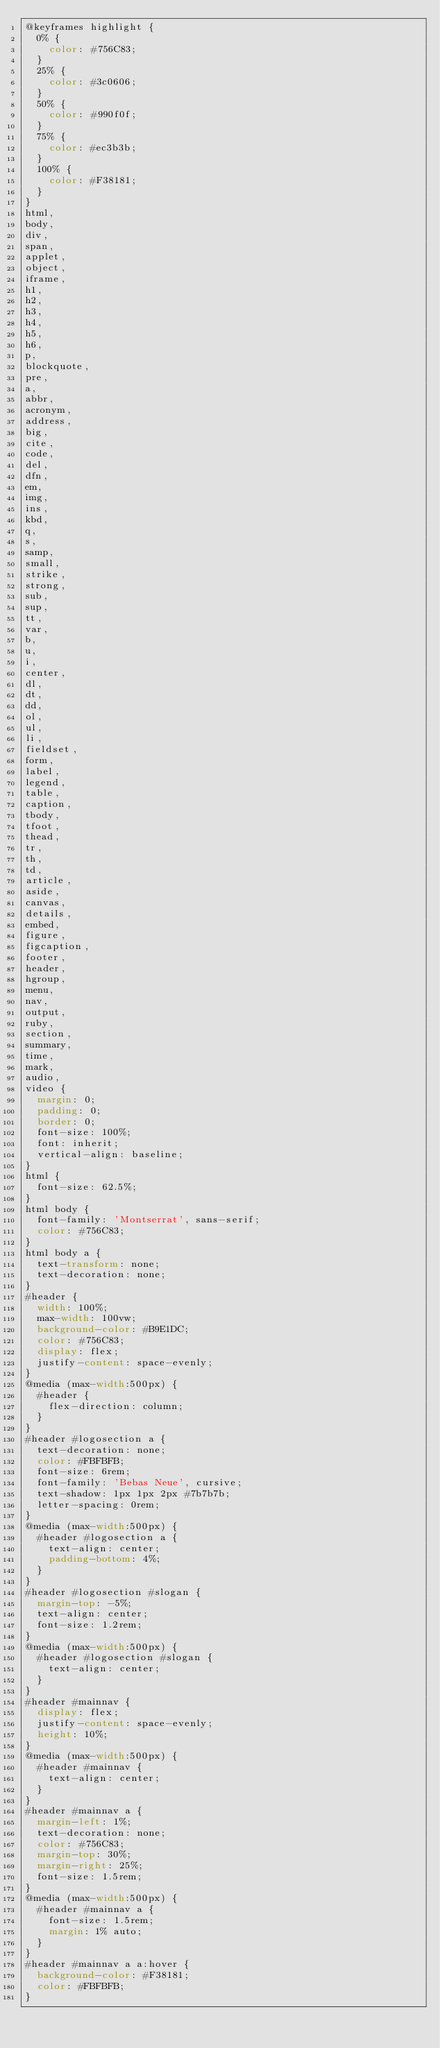Convert code to text. <code><loc_0><loc_0><loc_500><loc_500><_CSS_>@keyframes highlight {
  0% {
    color: #756C83;
  }
  25% {
    color: #3c0606;
  }
  50% {
    color: #990f0f;
  }
  75% {
    color: #ec3b3b;
  }
  100% {
    color: #F38181;
  }
}
html,
body,
div,
span,
applet,
object,
iframe,
h1,
h2,
h3,
h4,
h5,
h6,
p,
blockquote,
pre,
a,
abbr,
acronym,
address,
big,
cite,
code,
del,
dfn,
em,
img,
ins,
kbd,
q,
s,
samp,
small,
strike,
strong,
sub,
sup,
tt,
var,
b,
u,
i,
center,
dl,
dt,
dd,
ol,
ul,
li,
fieldset,
form,
label,
legend,
table,
caption,
tbody,
tfoot,
thead,
tr,
th,
td,
article,
aside,
canvas,
details,
embed,
figure,
figcaption,
footer,
header,
hgroup,
menu,
nav,
output,
ruby,
section,
summary,
time,
mark,
audio,
video {
  margin: 0;
  padding: 0;
  border: 0;
  font-size: 100%;
  font: inherit;
  vertical-align: baseline;
}
html {
  font-size: 62.5%;
}
html body {
  font-family: 'Montserrat', sans-serif;
  color: #756C83;
}
html body a {
  text-transform: none;
  text-decoration: none;
}
#header {
  width: 100%;
  max-width: 100vw;
  background-color: #B9E1DC;
  color: #756C83;
  display: flex;
  justify-content: space-evenly;
}
@media (max-width:500px) {
  #header {
    flex-direction: column;
  }
}
#header #logosection a {
  text-decoration: none;
  color: #FBFBFB;
  font-size: 6rem;
  font-family: 'Bebas Neue', cursive;
  text-shadow: 1px 1px 2px #7b7b7b;
  letter-spacing: 0rem;
}
@media (max-width:500px) {
  #header #logosection a {
    text-align: center;
    padding-bottom: 4%;
  }
}
#header #logosection #slogan {
  margin-top: -5%;
  text-align: center;
  font-size: 1.2rem;
}
@media (max-width:500px) {
  #header #logosection #slogan {
    text-align: center;
  }
}
#header #mainnav {
  display: flex;
  justify-content: space-evenly;
  height: 10%;
}
@media (max-width:500px) {
  #header #mainnav {
    text-align: center;
  }
}
#header #mainnav a {
  margin-left: 1%;
  text-decoration: none;
  color: #756C83;
  margin-top: 30%;
  margin-right: 25%;
  font-size: 1.5rem;
}
@media (max-width:500px) {
  #header #mainnav a {
    font-size: 1.5rem;
    margin: 1% auto;
  }
}
#header #mainnav a a:hover {
  background-color: #F38181;
  color: #FBFBFB;
}</code> 